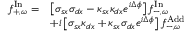Convert formula to latex. <formula><loc_0><loc_0><loc_500><loc_500>\begin{array} { r l } { f _ { + , \omega } ^ { I n } = } & { \left [ \sigma _ { s x } \sigma _ { d x } - \kappa _ { s x } \kappa _ { d x } e ^ { i \Delta \phi } \right ] f _ { - , \omega } ^ { I n } } \\ & { + i \left [ \sigma _ { s x } \kappa _ { d x } + \kappa _ { s x } \sigma _ { d x } e ^ { i \Delta \phi } \right ] f _ { - , \omega } ^ { A d d } } \end{array}</formula> 